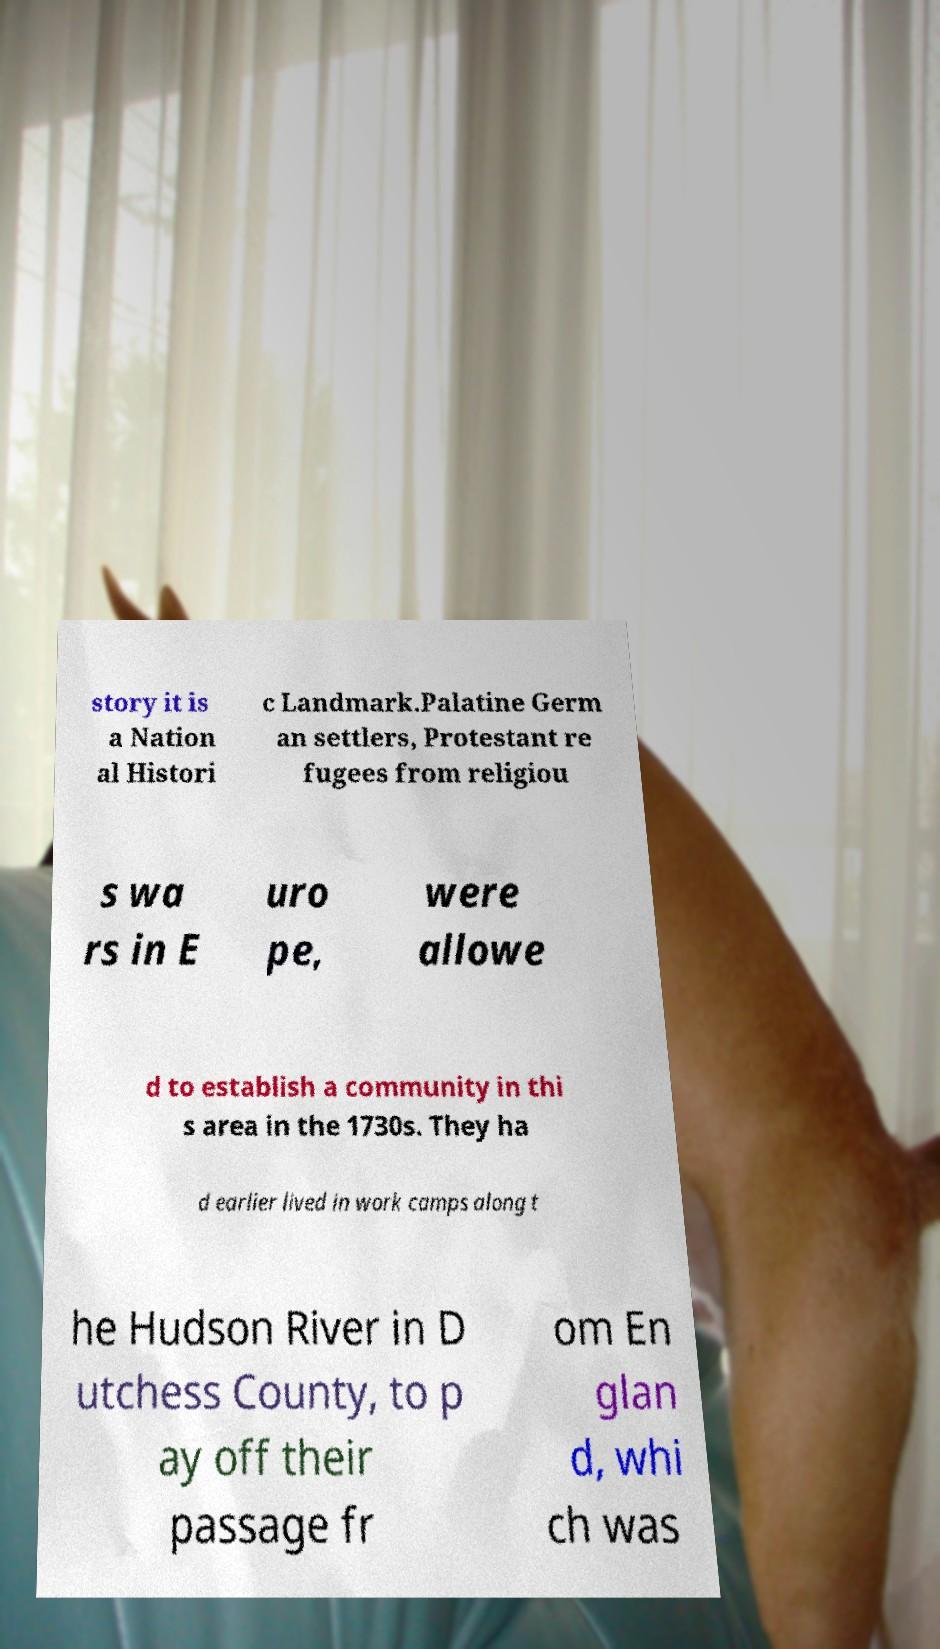Can you accurately transcribe the text from the provided image for me? story it is a Nation al Histori c Landmark.Palatine Germ an settlers, Protestant re fugees from religiou s wa rs in E uro pe, were allowe d to establish a community in thi s area in the 1730s. They ha d earlier lived in work camps along t he Hudson River in D utchess County, to p ay off their passage fr om En glan d, whi ch was 